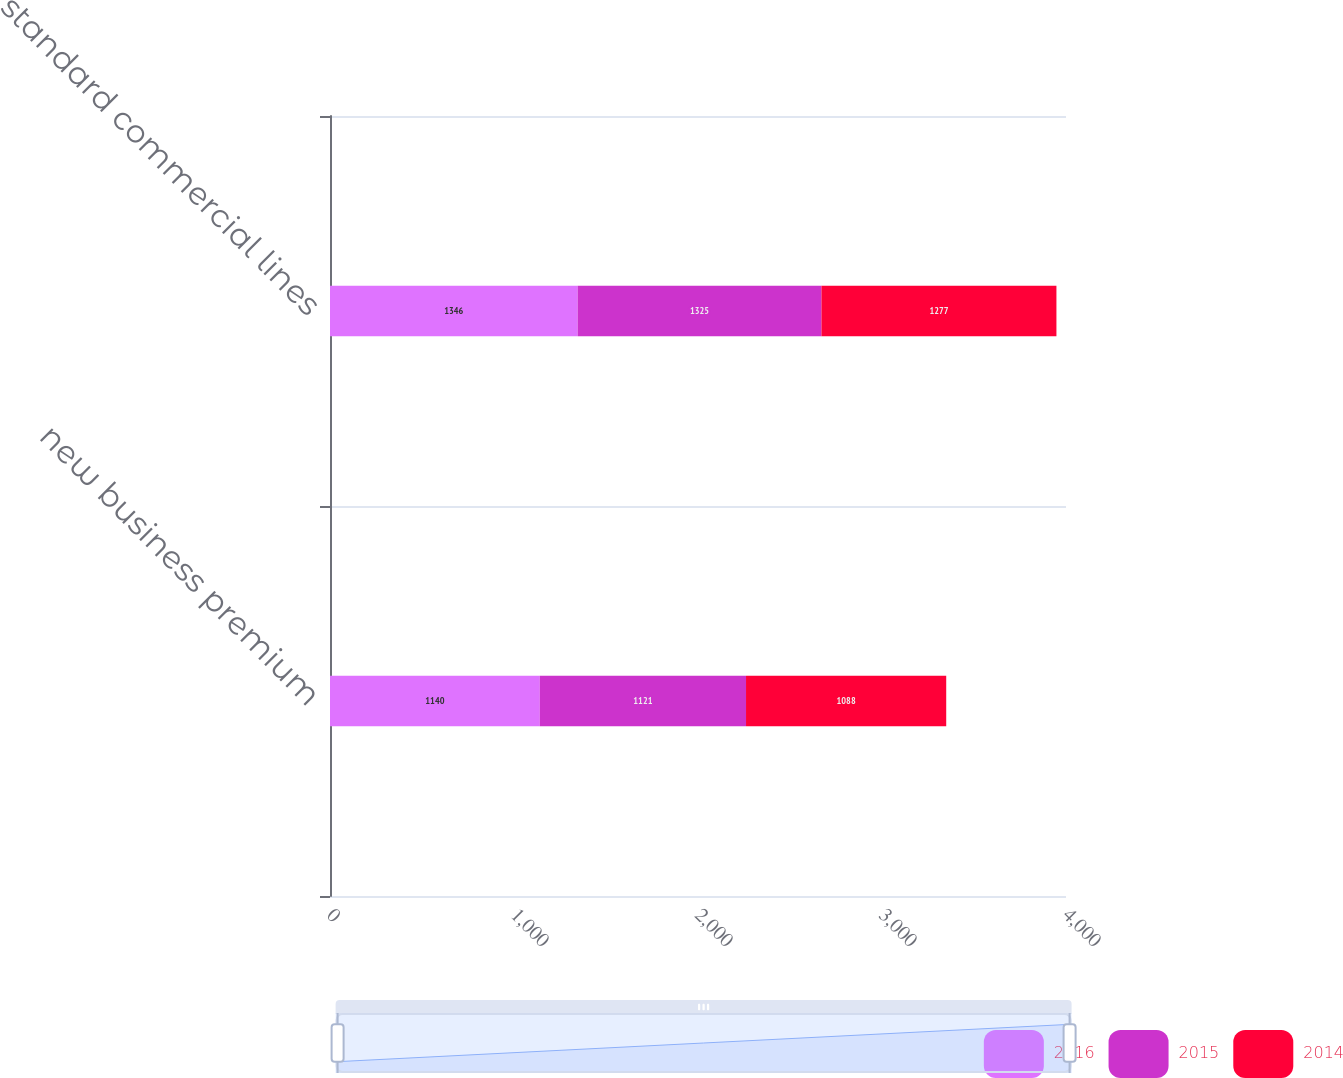Convert chart to OTSL. <chart><loc_0><loc_0><loc_500><loc_500><stacked_bar_chart><ecel><fcel>new business premium<fcel>standard commercial lines<nl><fcel>2016<fcel>1140<fcel>1346<nl><fcel>2015<fcel>1121<fcel>1325<nl><fcel>2014<fcel>1088<fcel>1277<nl></chart> 